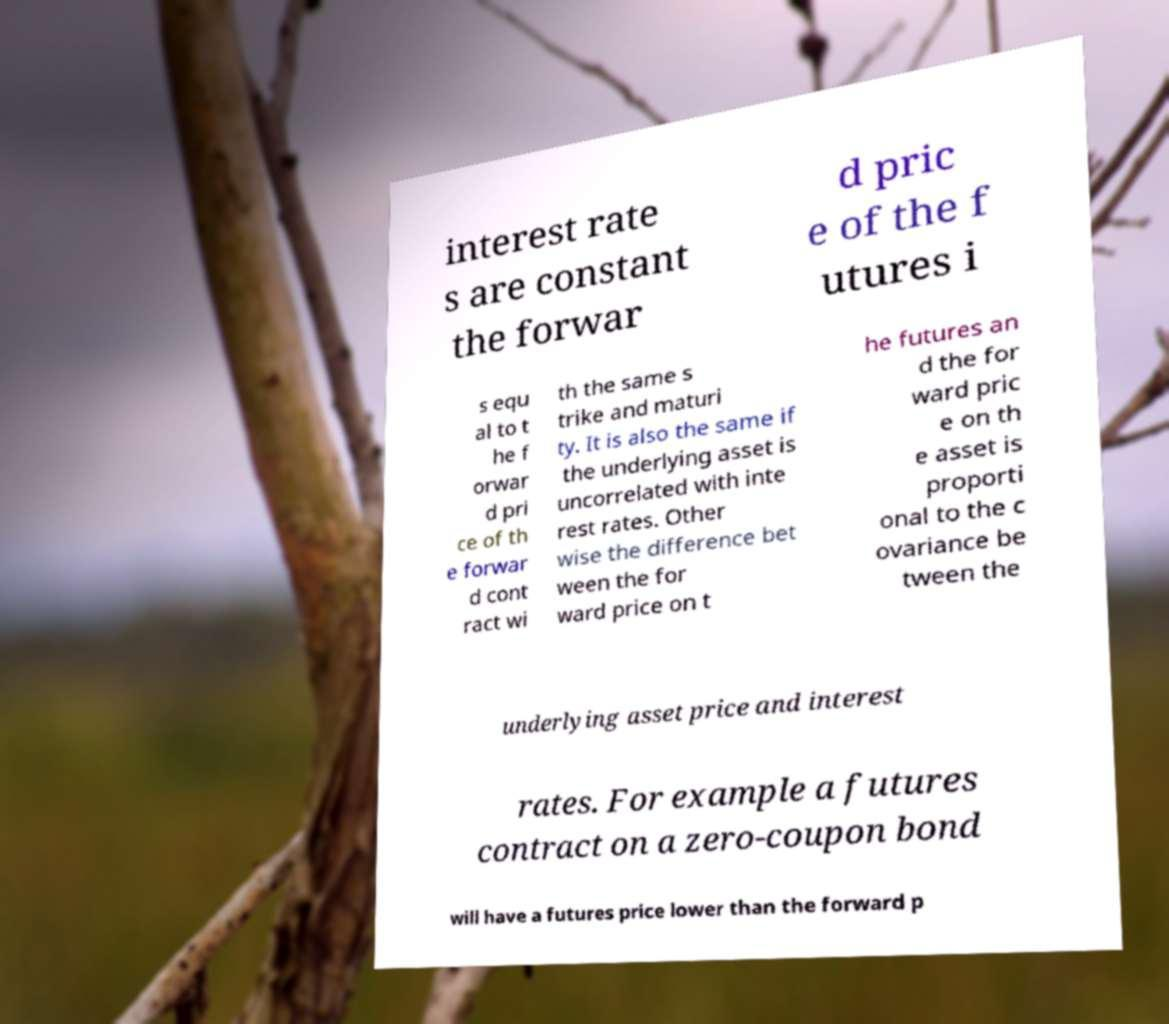Could you extract and type out the text from this image? interest rate s are constant the forwar d pric e of the f utures i s equ al to t he f orwar d pri ce of th e forwar d cont ract wi th the same s trike and maturi ty. It is also the same if the underlying asset is uncorrelated with inte rest rates. Other wise the difference bet ween the for ward price on t he futures an d the for ward pric e on th e asset is proporti onal to the c ovariance be tween the underlying asset price and interest rates. For example a futures contract on a zero-coupon bond will have a futures price lower than the forward p 